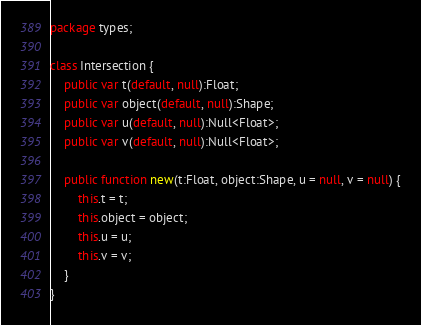Convert code to text. <code><loc_0><loc_0><loc_500><loc_500><_Haxe_>package types;

class Intersection {
	public var t(default, null):Float;
	public var object(default, null):Shape;
	public var u(default, null):Null<Float>;
	public var v(default, null):Null<Float>;

	public function new(t:Float, object:Shape, u = null, v = null) {
		this.t = t;
		this.object = object;
		this.u = u;
		this.v = v;
	}
}
</code> 